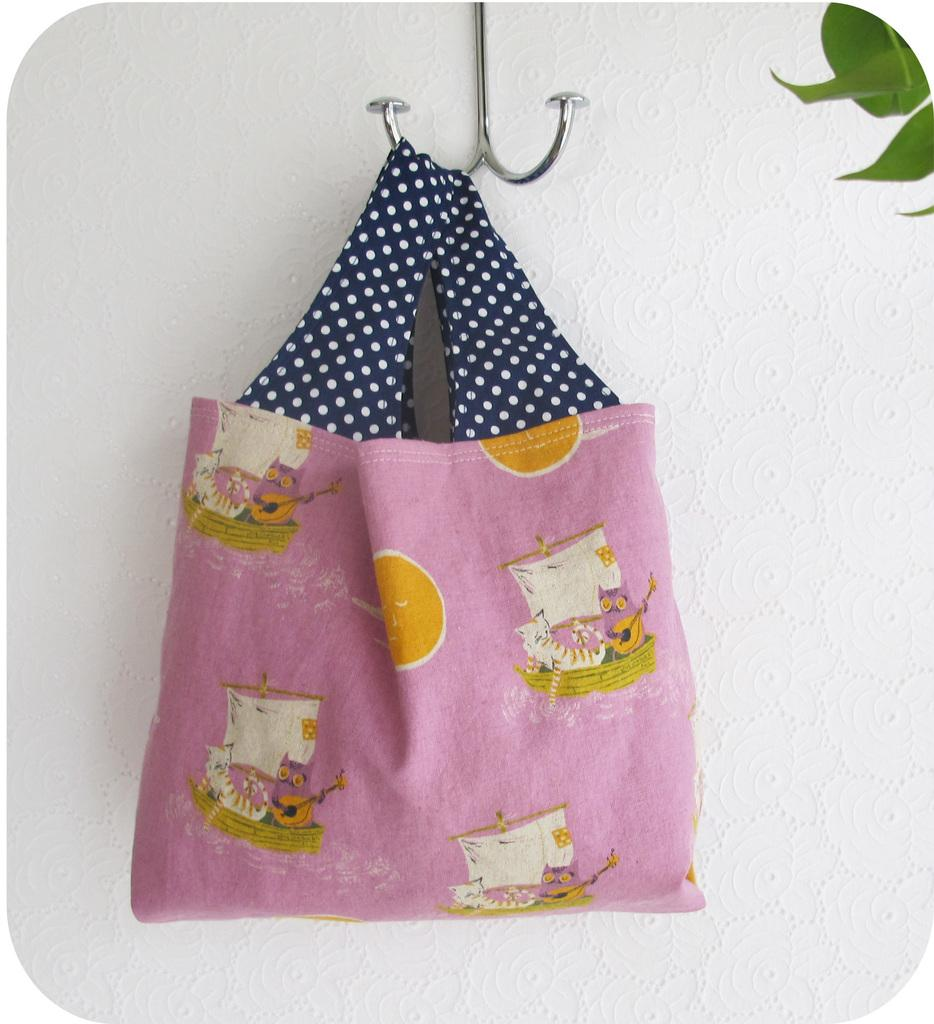What type of accessory is present in the image? There is a handbag in the image. What color is the handbag? The handbag is pink in color. What type of bean is growing out of the handbag in the image? There are no beans present in the image, and the handbag is not associated with any bean growth. 